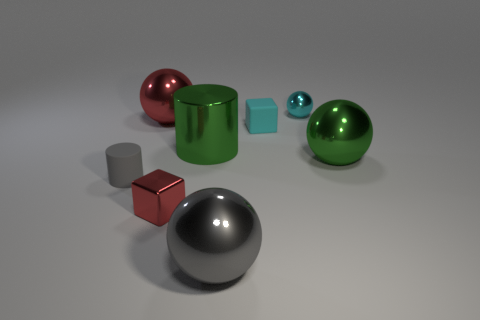Subtract all small cyan shiny spheres. How many spheres are left? 3 Add 1 small yellow rubber cylinders. How many objects exist? 9 Subtract all gray spheres. How many spheres are left? 3 Subtract all blocks. How many objects are left? 6 Add 8 tiny yellow rubber cubes. How many tiny yellow rubber cubes exist? 8 Subtract 1 green balls. How many objects are left? 7 Subtract all purple balls. Subtract all red cubes. How many balls are left? 4 Subtract all blue metallic spheres. Subtract all tiny gray matte things. How many objects are left? 7 Add 6 matte cubes. How many matte cubes are left? 7 